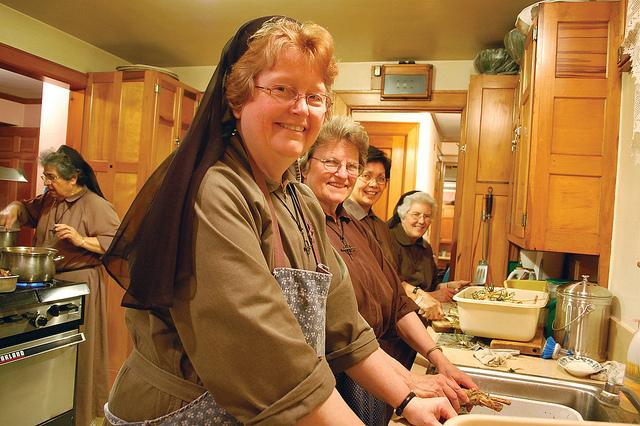What religion are these women?
Concise answer only. Christian. Do the ladies have any bad habits?
Concise answer only. No. How many ladies have on glasses?
Write a very short answer. 5. Are these women in a restaurant?
Write a very short answer. No. 